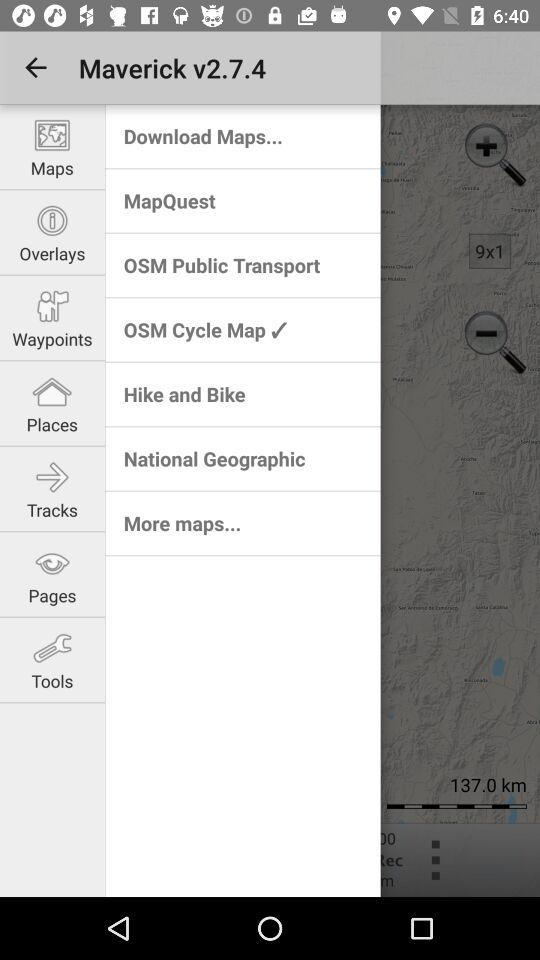Which option is checked marked? The option is "OSM Cycle Map". 